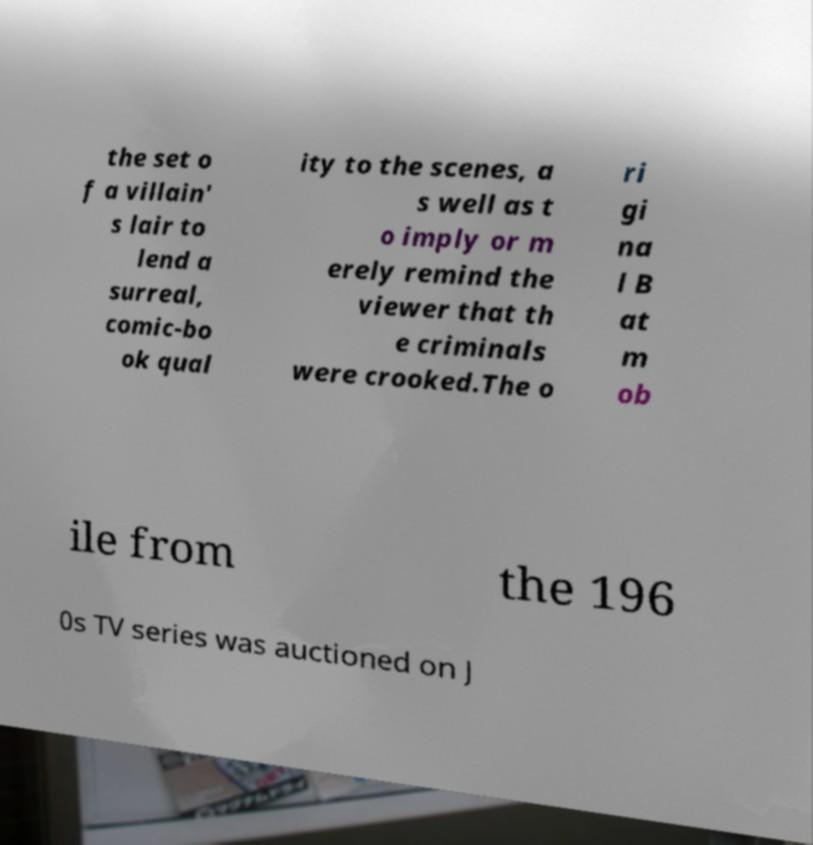I need the written content from this picture converted into text. Can you do that? the set o f a villain' s lair to lend a surreal, comic-bo ok qual ity to the scenes, a s well as t o imply or m erely remind the viewer that th e criminals were crooked.The o ri gi na l B at m ob ile from the 196 0s TV series was auctioned on J 